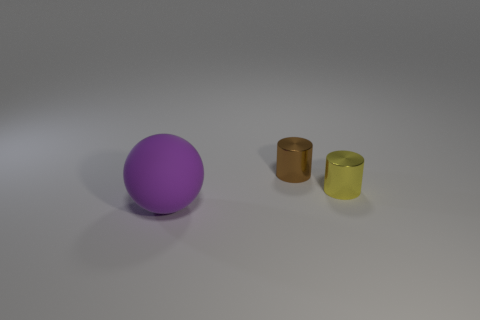Add 2 matte objects. How many objects exist? 5 Subtract all cylinders. How many objects are left? 1 Add 3 purple rubber objects. How many purple rubber objects exist? 4 Subtract 0 cyan spheres. How many objects are left? 3 Subtract all purple cylinders. Subtract all gray balls. How many cylinders are left? 2 Subtract all large red rubber cylinders. Subtract all tiny yellow things. How many objects are left? 2 Add 1 tiny yellow shiny cylinders. How many tiny yellow shiny cylinders are left? 2 